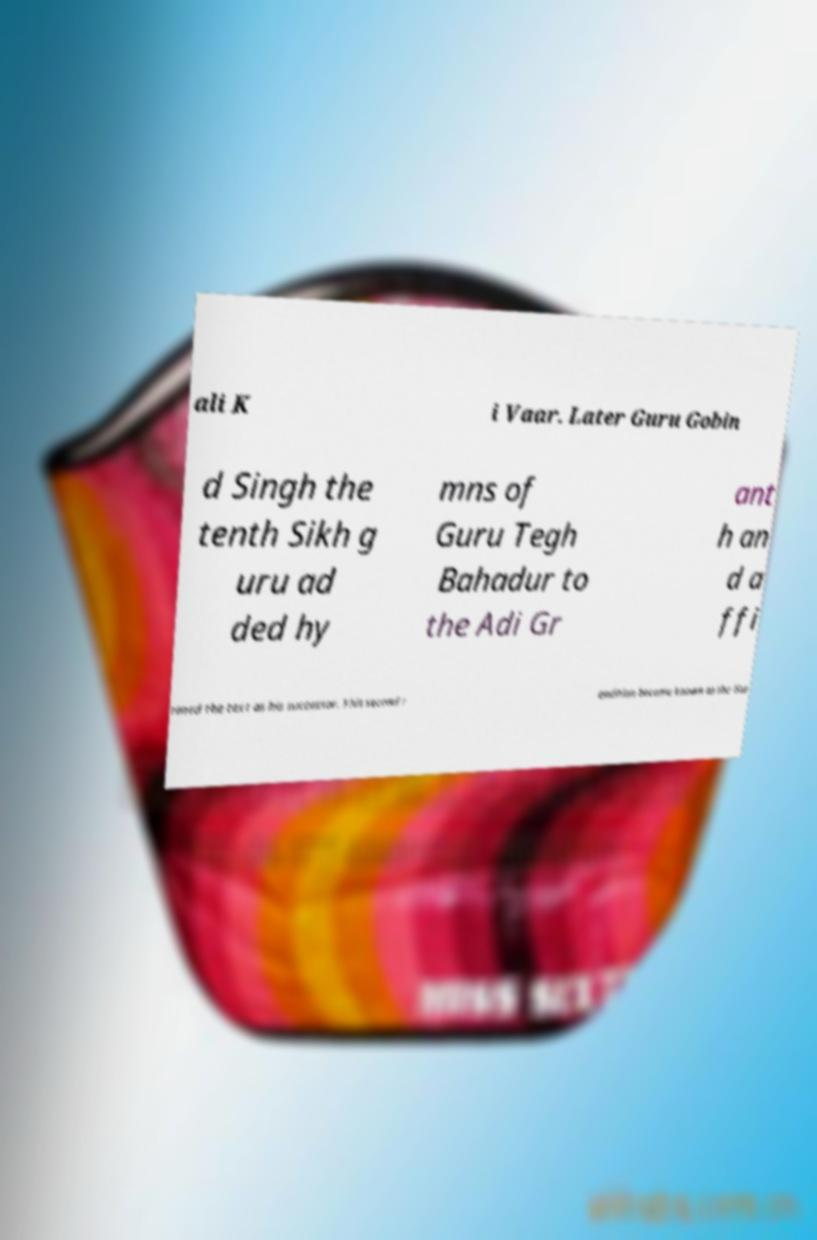Could you extract and type out the text from this image? ali K i Vaar. Later Guru Gobin d Singh the tenth Sikh g uru ad ded hy mns of Guru Tegh Bahadur to the Adi Gr ant h an d a ffi rmed the text as his successor. This second r endition became known as the Gur 